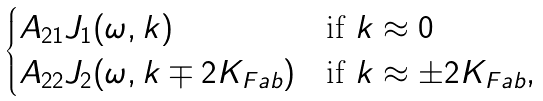Convert formula to latex. <formula><loc_0><loc_0><loc_500><loc_500>\begin{cases} A _ { 2 1 } J _ { 1 } ( \omega , k ) & \text {if $k\approx 0$} \\ A _ { 2 2 } J _ { 2 } ( \omega , k \mp 2 K _ { F a b } ) & \text {if $k\approx \pm 2K_{Fab}$} , \\ \end{cases}</formula> 